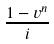Convert formula to latex. <formula><loc_0><loc_0><loc_500><loc_500>\frac { 1 - v ^ { n } } { i }</formula> 